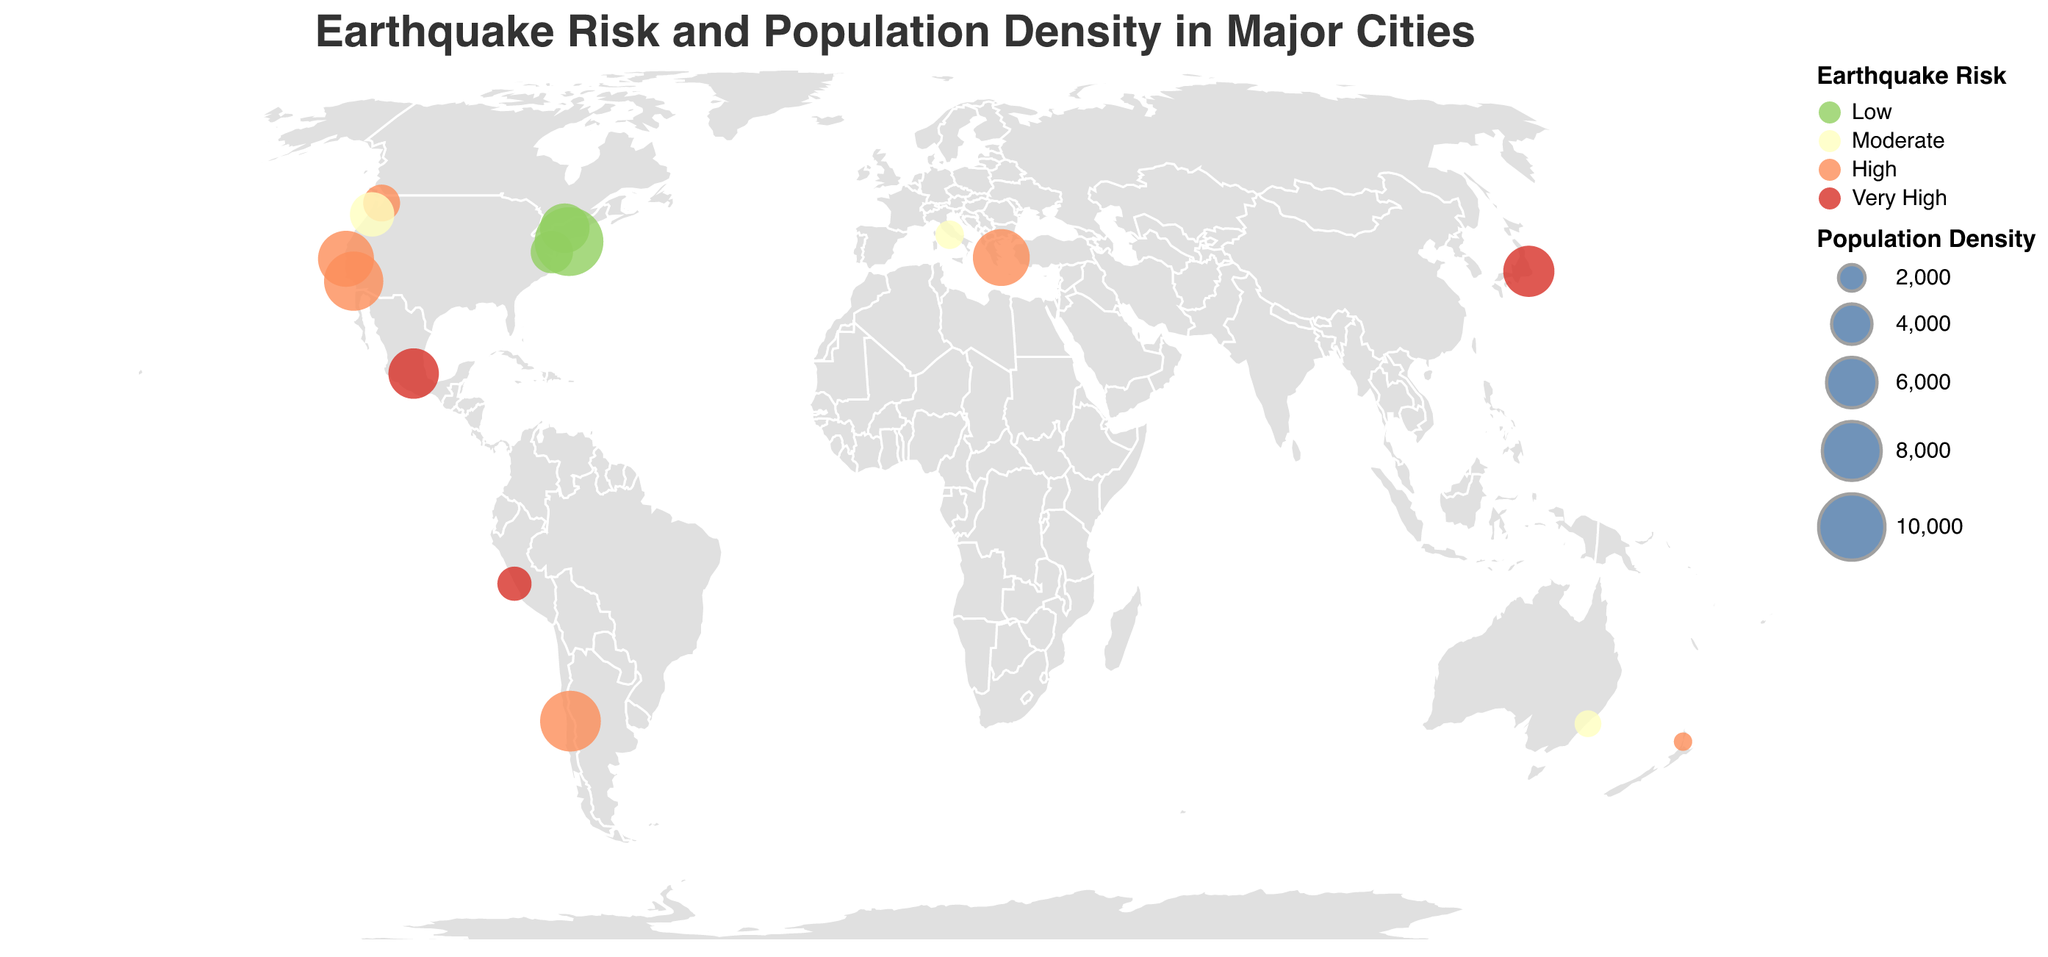What's the title of the figure? The title of the figure is located at the top and is prominent in both size and placement. It reads, "Earthquake Risk and Population Density in Major Cities."
Answer: Earthquake Risk and Population Density in Major Cities How is population density represented in the plot? Population density is represented by the size of circles at various geographic locations. Larger circles indicate higher population densities.
Answer: By the size of the circles Which city has the highest earthquake risk and also a very high population density? The color coding for 'Very High' earthquake risk is red and the size of the circle represents population density. Tokyo and Mexico City have red-colored and relatively large circles.
Answer: Tokyo Which city has the highest population density but the lowest earthquake risk? The largest circle with a green color (indicating 'Low' earthquake risk) belongs to New York City.
Answer: New York City Compare the population densities of San Francisco and Los Angeles. Which one is higher? Both San Francisco and Los Angeles have 'High' earthquake risk indicated by orange, but the size of San Francisco's circle is smaller than Los Angeles's.
Answer: Los Angeles What's the average population density for cities with high earthquake risk? The cities with high earthquake risk (orange circles) are San Francisco (7272), Los Angeles (8092), Seattle (3429), Athens (7483), Santiago (8470), and Auckland (1210). The average is calculated by summing the densities and dividing by the number of cities: (7272 + 8092 + 3429 + 7483 + 8470 + 1210) / 6 = 5992.67.
Answer: 5992.67 How are different earthquake risk levels represented by colors in the plot? Different earthquake risk levels are shown using distinct colors: Low (green), Moderate (yellow), High (orange), and Very High (red).
Answer: Green for Low, Yellow for Moderate, Orange for High, Red for Very High Which region has the lowest population density among those with moderate earthquake risk? Moderate earthquake risk is shown in yellow circles. Among them, Rome has the smallest circle, indicating the lowest population density.
Answer: Rome Which cities fall into the 'Very High' earthquake risk category, and how can you identify them? Cities with 'Very High' earthquake risk are shown in red circles. These cities are Tokyo, Mexico City, and Lima.
Answer: Tokyo, Mexico City, Lima 